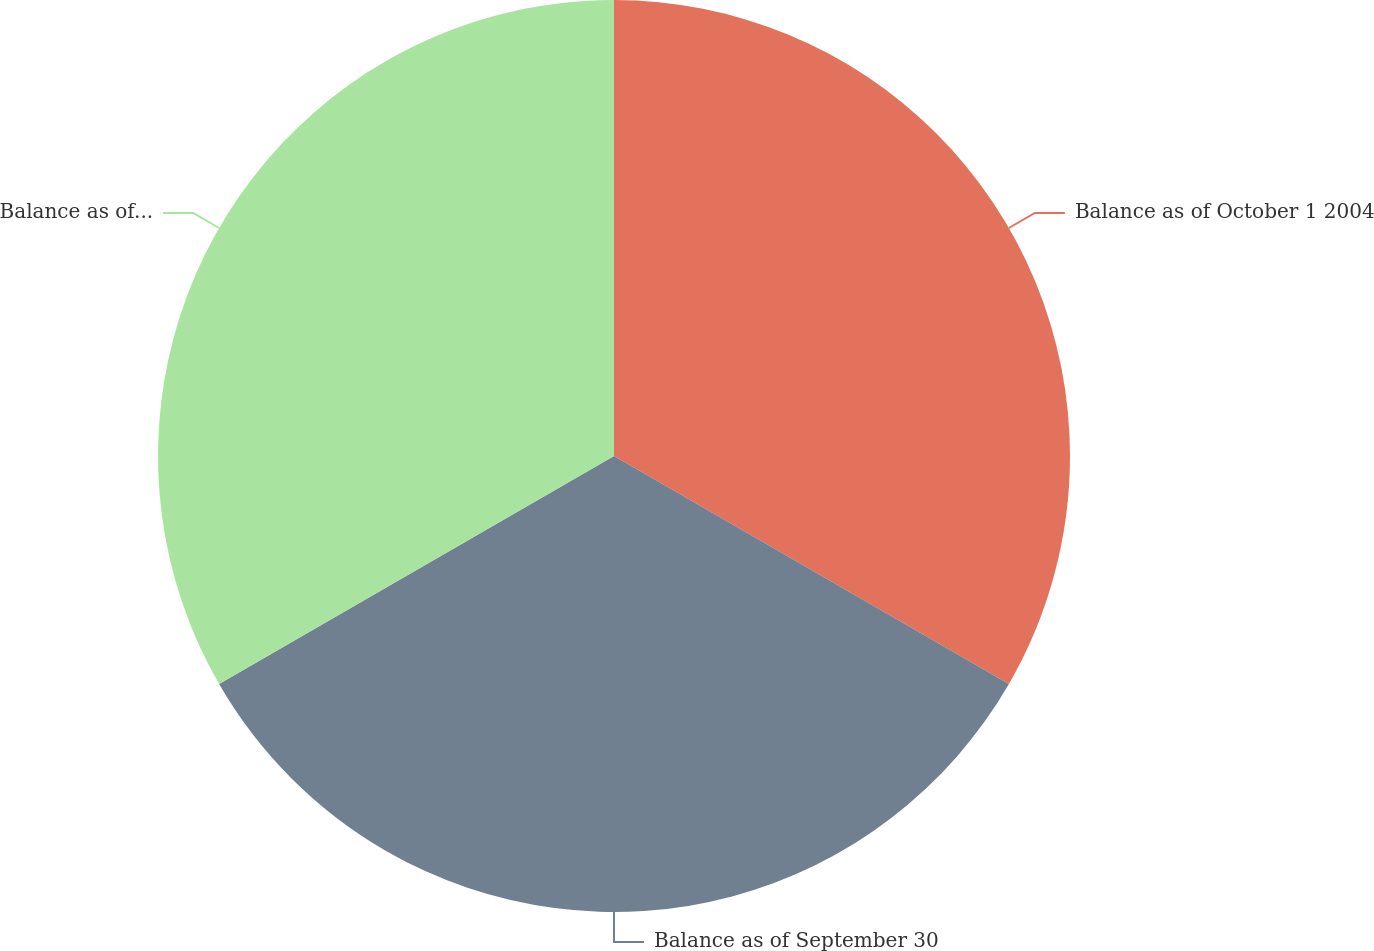Convert chart. <chart><loc_0><loc_0><loc_500><loc_500><pie_chart><fcel>Balance as of October 1 2004<fcel>Balance as of September 30<fcel>Balance as of September 29<nl><fcel>33.33%<fcel>33.33%<fcel>33.33%<nl></chart> 